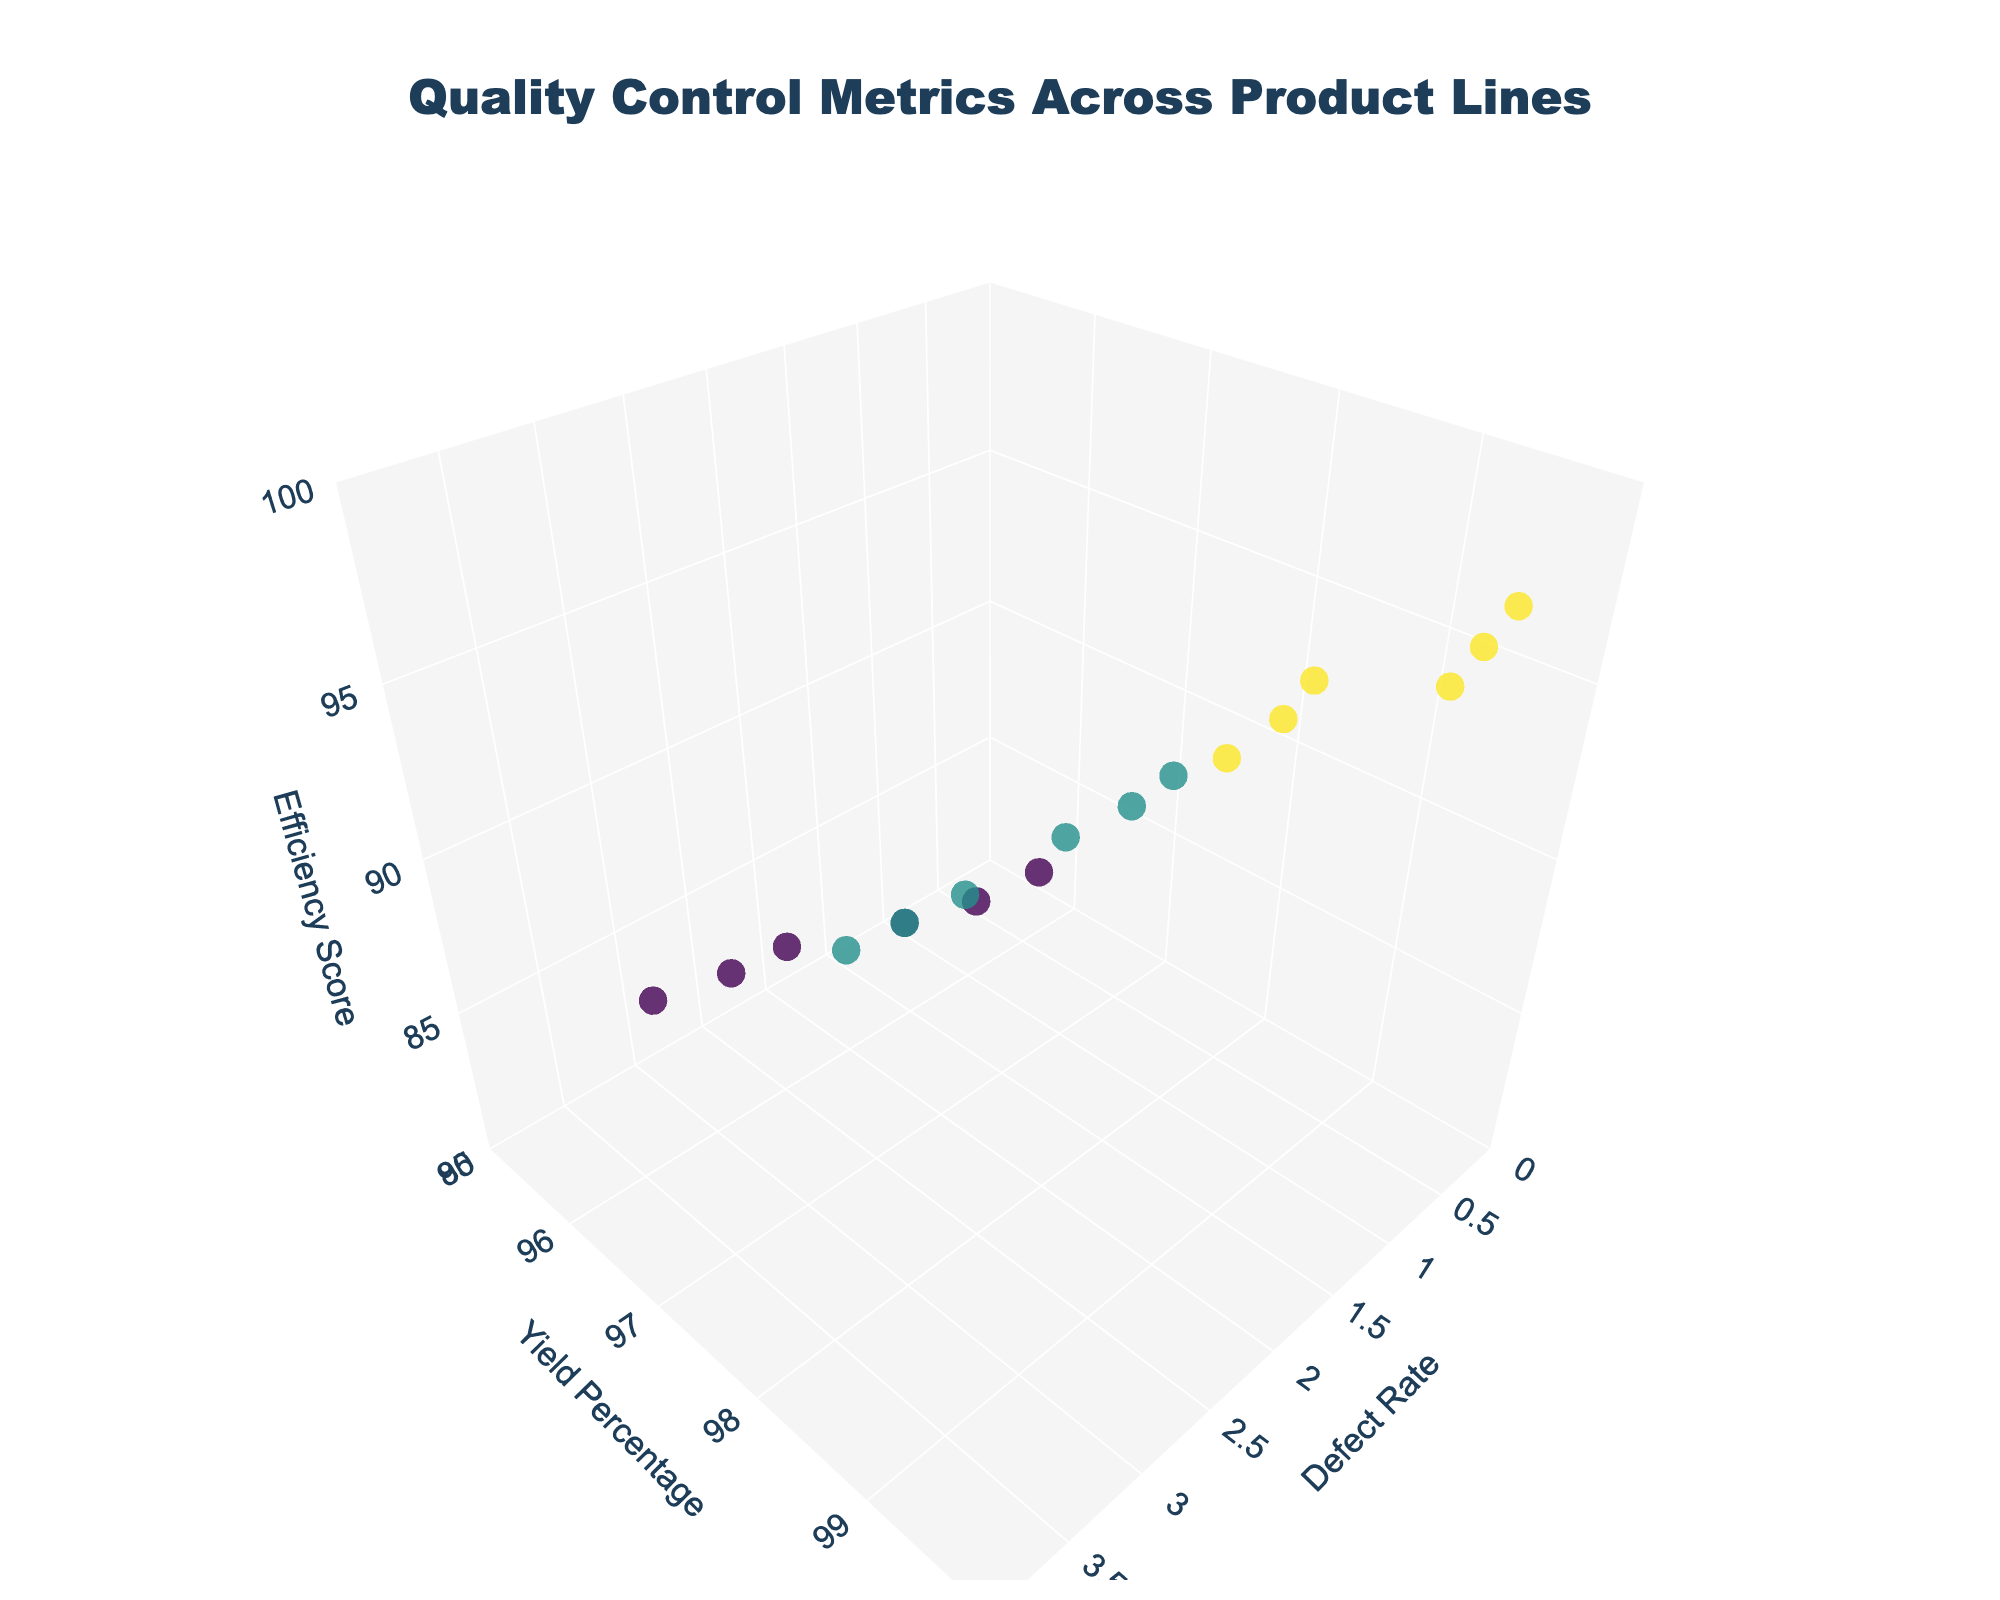What's the title of the plot? The title is located at the top of the plot. It is written in a larger, bold font to distinguish it from other textual elements.
Answer: Quality Control Metrics Across Product Lines What do the axes on the 3D plot represent? The axes are labeled to represent specific metrics. The x-axis is labeled "Defect Rate," the y-axis is labeled "Yield Percentage," and the z-axis is labeled "Efficiency Score."
Answer: Defect Rate, Yield Percentage, Efficiency Score How many product lines are represented in the plot? The color bar on the right side of the plot shows different colors corresponding to each product line. The ticktext for the color bar indicates the names of these product lines.
Answer: 3 Which data point has the highest Efficiency Score in the plot? Locate the highest point along the z-axis labeled "Efficiency Score". Hovering over the data points shows their detailed information, including the product line, production stage, and time period.
Answer: Medical Devices, Sterilization, Q3 2023 What range does the Yield Percentage cover in this plot? The y-axis labeled "Yield Percentage" has its range defined by the axis ticks. By examining the ticks, the minimum and maximum values can be determined.
Answer: 95 to 100 Which production stage in Automotive Parts has the lowest Defect Rate for Q3 2023? Identify the data points related to Automotive Parts and check their Defect Rates for Q3 2023. Compare these rates to determine the lowest.
Answer: Assembly Is the average Yield Percentage for Medical Devices higher than that for Electronics? Calculate the average Yield Percentage for Medical Devices and Electronics by summing their respective Yield Percentages and dividing by the number of data points in each group. Compare the averages. Detailed steps: Medical Devices (99.4+99.5+99.6+98.5+98.7+98.8)/6 = 99.08, Electronics (97.9+98.2+98.4+96.8+97.1+97.4)/6 = 97.63
Answer: Yes Which product line shows improvement over time in all three metrics? Analyze each product line by examining the trend in Defect Rate, Yield Percentage, and Efficiency Score over the Q1 to Q3 time periods. Improvement is indicated by a decreasing trend in Defect Rate and increasing trends in Yield Percentage and Efficiency Score. Detailed steps: Check Automotive Parts, Electronics, and Medical Devices separately for all three metrics. Only Medical Devices show improvement in all three metrics over time
Answer: Medical Devices Are there any outliers in the Efficiency Score data? If so, identify them. Outliers can be identified by visually inspecting data points that significantly deviate from the overall distribution along the z-axis. Data points much higher or lower than the rest suggest outliers.
Answer: No outliers 